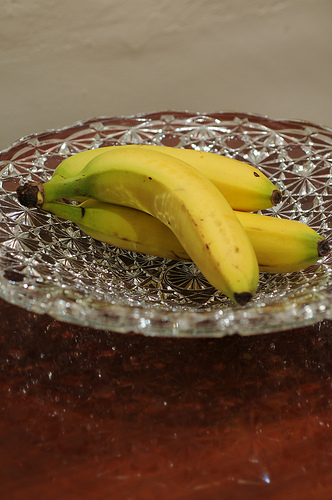<image>
Is the banana in the glass dish? Yes. The banana is contained within or inside the glass dish, showing a containment relationship. 